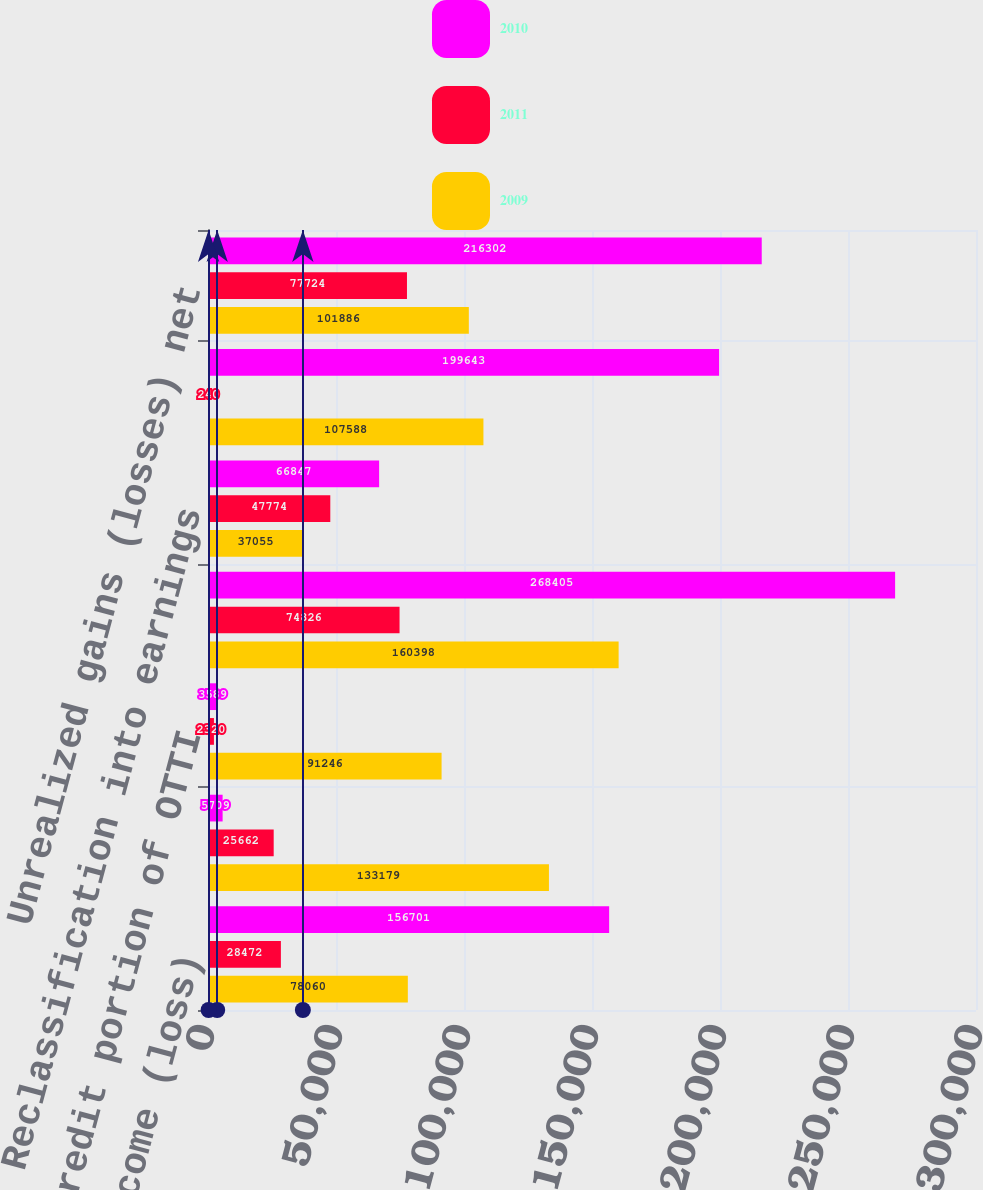<chart> <loc_0><loc_0><loc_500><loc_500><stacked_bar_chart><ecel><fcel>Net income (loss)<fcel>OTTI net (1)<fcel>Noncredit portion of OTTI<fcel>Unrealized gains net (3)<fcel>Reclassification into earnings<fcel>Net change from<fcel>Unrealized gains (losses) net<nl><fcel>2010<fcel>156701<fcel>5709<fcel>3589<fcel>268405<fcel>66847<fcel>199643<fcel>216302<nl><fcel>2011<fcel>28472<fcel>25662<fcel>2320<fcel>74826<fcel>47774<fcel>240<fcel>77724<nl><fcel>2009<fcel>78060<fcel>133179<fcel>91246<fcel>160398<fcel>37055<fcel>107588<fcel>101886<nl></chart> 